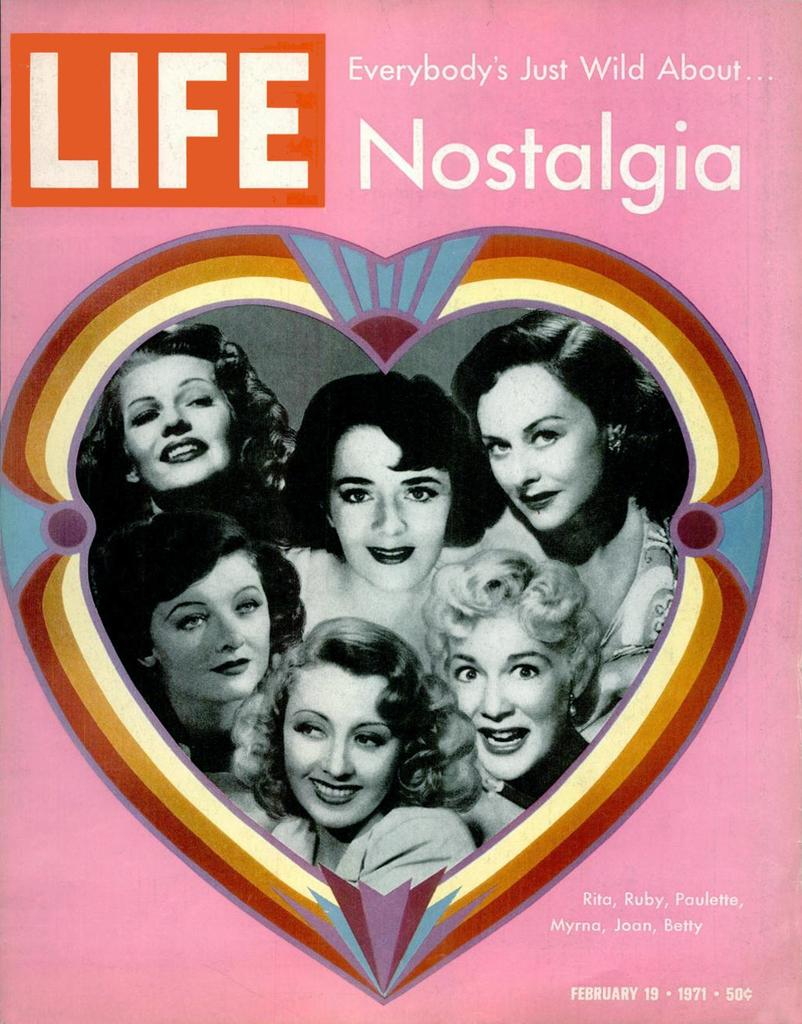What is the main subject of the image? There is a poster in the image. What can be seen on the poster? The poster contains six women's photos. Where is the text located on the poster? There is text at the top of the poster and in the bottom right corner of the poster. What type of roof can be seen on the women's heads in the image? There are no roofs visible in the image; it features a poster with six women's photos. How many sisters are present in the image? There is no mention of sisters in the image; it features a poster with six women's photos. 